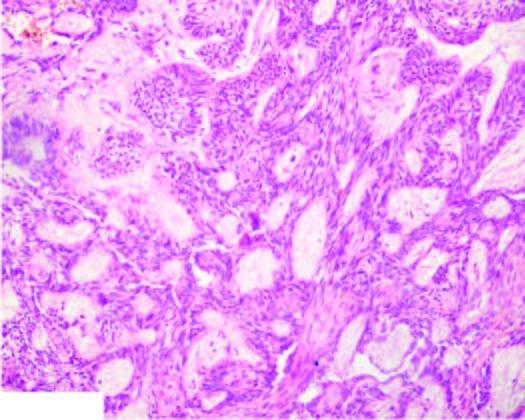what do plexiform areas show?
Answer the question using a single word or phrase. Irregular masses and network of strands of epithelial cells 